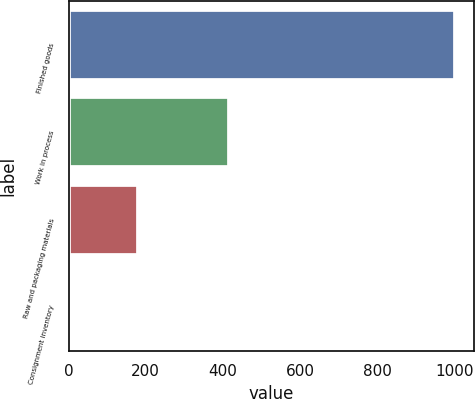<chart> <loc_0><loc_0><loc_500><loc_500><bar_chart><fcel>Finished goods<fcel>Work in process<fcel>Raw and packaging materials<fcel>Consignment inventory<nl><fcel>1001<fcel>416<fcel>180<fcel>4<nl></chart> 